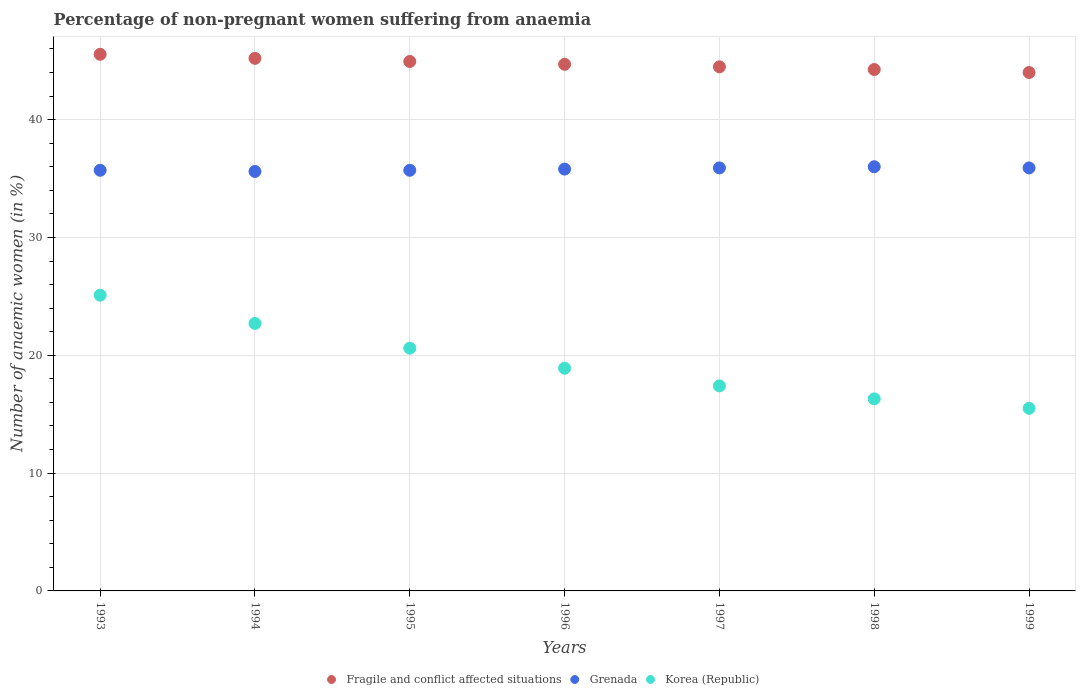Is the number of dotlines equal to the number of legend labels?
Your answer should be very brief. Yes. What is the percentage of non-pregnant women suffering from anaemia in Fragile and conflict affected situations in 1994?
Ensure brevity in your answer.  45.2. Across all years, what is the maximum percentage of non-pregnant women suffering from anaemia in Fragile and conflict affected situations?
Offer a terse response. 45.54. In which year was the percentage of non-pregnant women suffering from anaemia in Korea (Republic) maximum?
Your answer should be compact. 1993. In which year was the percentage of non-pregnant women suffering from anaemia in Korea (Republic) minimum?
Offer a very short reply. 1999. What is the total percentage of non-pregnant women suffering from anaemia in Grenada in the graph?
Offer a very short reply. 250.6. What is the difference between the percentage of non-pregnant women suffering from anaemia in Grenada in 1996 and that in 1999?
Provide a succinct answer. -0.1. What is the difference between the percentage of non-pregnant women suffering from anaemia in Fragile and conflict affected situations in 1993 and the percentage of non-pregnant women suffering from anaemia in Korea (Republic) in 1995?
Your response must be concise. 24.94. What is the average percentage of non-pregnant women suffering from anaemia in Korea (Republic) per year?
Ensure brevity in your answer.  19.5. What is the ratio of the percentage of non-pregnant women suffering from anaemia in Fragile and conflict affected situations in 1995 to that in 1997?
Offer a very short reply. 1.01. Is the percentage of non-pregnant women suffering from anaemia in Grenada in 1997 less than that in 1999?
Your answer should be compact. No. Is the difference between the percentage of non-pregnant women suffering from anaemia in Grenada in 1995 and 1998 greater than the difference between the percentage of non-pregnant women suffering from anaemia in Korea (Republic) in 1995 and 1998?
Ensure brevity in your answer.  No. What is the difference between the highest and the second highest percentage of non-pregnant women suffering from anaemia in Grenada?
Your answer should be compact. 0.1. What is the difference between the highest and the lowest percentage of non-pregnant women suffering from anaemia in Grenada?
Keep it short and to the point. 0.4. Is the sum of the percentage of non-pregnant women suffering from anaemia in Grenada in 1993 and 1994 greater than the maximum percentage of non-pregnant women suffering from anaemia in Fragile and conflict affected situations across all years?
Your answer should be very brief. Yes. Does the percentage of non-pregnant women suffering from anaemia in Korea (Republic) monotonically increase over the years?
Give a very brief answer. No. Is the percentage of non-pregnant women suffering from anaemia in Fragile and conflict affected situations strictly greater than the percentage of non-pregnant women suffering from anaemia in Grenada over the years?
Make the answer very short. Yes. What is the difference between two consecutive major ticks on the Y-axis?
Ensure brevity in your answer.  10. Does the graph contain any zero values?
Make the answer very short. No. What is the title of the graph?
Make the answer very short. Percentage of non-pregnant women suffering from anaemia. Does "Mauritania" appear as one of the legend labels in the graph?
Your answer should be compact. No. What is the label or title of the X-axis?
Your response must be concise. Years. What is the label or title of the Y-axis?
Your answer should be very brief. Number of anaemic women (in %). What is the Number of anaemic women (in %) of Fragile and conflict affected situations in 1993?
Provide a short and direct response. 45.54. What is the Number of anaemic women (in %) in Grenada in 1993?
Offer a terse response. 35.7. What is the Number of anaemic women (in %) of Korea (Republic) in 1993?
Your answer should be compact. 25.1. What is the Number of anaemic women (in %) of Fragile and conflict affected situations in 1994?
Offer a very short reply. 45.2. What is the Number of anaemic women (in %) in Grenada in 1994?
Your answer should be very brief. 35.6. What is the Number of anaemic women (in %) of Korea (Republic) in 1994?
Provide a short and direct response. 22.7. What is the Number of anaemic women (in %) of Fragile and conflict affected situations in 1995?
Provide a short and direct response. 44.93. What is the Number of anaemic women (in %) in Grenada in 1995?
Your response must be concise. 35.7. What is the Number of anaemic women (in %) in Korea (Republic) in 1995?
Your answer should be very brief. 20.6. What is the Number of anaemic women (in %) of Fragile and conflict affected situations in 1996?
Your answer should be very brief. 44.69. What is the Number of anaemic women (in %) in Grenada in 1996?
Your response must be concise. 35.8. What is the Number of anaemic women (in %) in Korea (Republic) in 1996?
Ensure brevity in your answer.  18.9. What is the Number of anaemic women (in %) of Fragile and conflict affected situations in 1997?
Your answer should be compact. 44.48. What is the Number of anaemic women (in %) in Grenada in 1997?
Your answer should be very brief. 35.9. What is the Number of anaemic women (in %) in Korea (Republic) in 1997?
Offer a terse response. 17.4. What is the Number of anaemic women (in %) in Fragile and conflict affected situations in 1998?
Provide a succinct answer. 44.25. What is the Number of anaemic women (in %) of Grenada in 1998?
Offer a terse response. 36. What is the Number of anaemic women (in %) in Korea (Republic) in 1998?
Make the answer very short. 16.3. What is the Number of anaemic women (in %) in Fragile and conflict affected situations in 1999?
Offer a terse response. 44. What is the Number of anaemic women (in %) of Grenada in 1999?
Your answer should be compact. 35.9. Across all years, what is the maximum Number of anaemic women (in %) in Fragile and conflict affected situations?
Your answer should be very brief. 45.54. Across all years, what is the maximum Number of anaemic women (in %) in Korea (Republic)?
Provide a short and direct response. 25.1. Across all years, what is the minimum Number of anaemic women (in %) in Fragile and conflict affected situations?
Provide a short and direct response. 44. Across all years, what is the minimum Number of anaemic women (in %) in Grenada?
Your answer should be very brief. 35.6. Across all years, what is the minimum Number of anaemic women (in %) of Korea (Republic)?
Provide a succinct answer. 15.5. What is the total Number of anaemic women (in %) in Fragile and conflict affected situations in the graph?
Ensure brevity in your answer.  313.1. What is the total Number of anaemic women (in %) in Grenada in the graph?
Your answer should be compact. 250.6. What is the total Number of anaemic women (in %) in Korea (Republic) in the graph?
Give a very brief answer. 136.5. What is the difference between the Number of anaemic women (in %) of Fragile and conflict affected situations in 1993 and that in 1994?
Give a very brief answer. 0.35. What is the difference between the Number of anaemic women (in %) of Grenada in 1993 and that in 1994?
Your answer should be compact. 0.1. What is the difference between the Number of anaemic women (in %) of Fragile and conflict affected situations in 1993 and that in 1995?
Ensure brevity in your answer.  0.61. What is the difference between the Number of anaemic women (in %) of Grenada in 1993 and that in 1995?
Provide a succinct answer. 0. What is the difference between the Number of anaemic women (in %) of Fragile and conflict affected situations in 1993 and that in 1996?
Your answer should be very brief. 0.85. What is the difference between the Number of anaemic women (in %) in Fragile and conflict affected situations in 1993 and that in 1997?
Your answer should be very brief. 1.07. What is the difference between the Number of anaemic women (in %) in Grenada in 1993 and that in 1997?
Offer a terse response. -0.2. What is the difference between the Number of anaemic women (in %) of Fragile and conflict affected situations in 1993 and that in 1998?
Provide a short and direct response. 1.29. What is the difference between the Number of anaemic women (in %) of Fragile and conflict affected situations in 1993 and that in 1999?
Provide a short and direct response. 1.55. What is the difference between the Number of anaemic women (in %) of Fragile and conflict affected situations in 1994 and that in 1995?
Provide a succinct answer. 0.27. What is the difference between the Number of anaemic women (in %) of Grenada in 1994 and that in 1995?
Offer a very short reply. -0.1. What is the difference between the Number of anaemic women (in %) of Korea (Republic) in 1994 and that in 1995?
Provide a short and direct response. 2.1. What is the difference between the Number of anaemic women (in %) in Fragile and conflict affected situations in 1994 and that in 1996?
Your answer should be compact. 0.51. What is the difference between the Number of anaemic women (in %) in Grenada in 1994 and that in 1996?
Your answer should be compact. -0.2. What is the difference between the Number of anaemic women (in %) of Korea (Republic) in 1994 and that in 1996?
Offer a terse response. 3.8. What is the difference between the Number of anaemic women (in %) in Fragile and conflict affected situations in 1994 and that in 1997?
Provide a succinct answer. 0.72. What is the difference between the Number of anaemic women (in %) in Grenada in 1994 and that in 1997?
Your answer should be very brief. -0.3. What is the difference between the Number of anaemic women (in %) in Korea (Republic) in 1994 and that in 1997?
Your response must be concise. 5.3. What is the difference between the Number of anaemic women (in %) in Fragile and conflict affected situations in 1994 and that in 1998?
Offer a terse response. 0.95. What is the difference between the Number of anaemic women (in %) of Fragile and conflict affected situations in 1994 and that in 1999?
Offer a very short reply. 1.2. What is the difference between the Number of anaemic women (in %) in Korea (Republic) in 1994 and that in 1999?
Provide a short and direct response. 7.2. What is the difference between the Number of anaemic women (in %) in Fragile and conflict affected situations in 1995 and that in 1996?
Keep it short and to the point. 0.24. What is the difference between the Number of anaemic women (in %) in Grenada in 1995 and that in 1996?
Offer a very short reply. -0.1. What is the difference between the Number of anaemic women (in %) of Fragile and conflict affected situations in 1995 and that in 1997?
Offer a terse response. 0.45. What is the difference between the Number of anaemic women (in %) in Fragile and conflict affected situations in 1995 and that in 1998?
Your answer should be compact. 0.68. What is the difference between the Number of anaemic women (in %) of Korea (Republic) in 1995 and that in 1998?
Provide a short and direct response. 4.3. What is the difference between the Number of anaemic women (in %) of Fragile and conflict affected situations in 1995 and that in 1999?
Provide a short and direct response. 0.94. What is the difference between the Number of anaemic women (in %) of Korea (Republic) in 1995 and that in 1999?
Make the answer very short. 5.1. What is the difference between the Number of anaemic women (in %) of Fragile and conflict affected situations in 1996 and that in 1997?
Make the answer very short. 0.21. What is the difference between the Number of anaemic women (in %) in Korea (Republic) in 1996 and that in 1997?
Offer a terse response. 1.5. What is the difference between the Number of anaemic women (in %) in Fragile and conflict affected situations in 1996 and that in 1998?
Provide a succinct answer. 0.44. What is the difference between the Number of anaemic women (in %) of Grenada in 1996 and that in 1998?
Offer a very short reply. -0.2. What is the difference between the Number of anaemic women (in %) of Fragile and conflict affected situations in 1996 and that in 1999?
Provide a short and direct response. 0.7. What is the difference between the Number of anaemic women (in %) in Fragile and conflict affected situations in 1997 and that in 1998?
Keep it short and to the point. 0.23. What is the difference between the Number of anaemic women (in %) of Grenada in 1997 and that in 1998?
Your answer should be very brief. -0.1. What is the difference between the Number of anaemic women (in %) of Fragile and conflict affected situations in 1997 and that in 1999?
Your answer should be very brief. 0.48. What is the difference between the Number of anaemic women (in %) in Korea (Republic) in 1997 and that in 1999?
Your answer should be compact. 1.9. What is the difference between the Number of anaemic women (in %) in Fragile and conflict affected situations in 1998 and that in 1999?
Provide a succinct answer. 0.25. What is the difference between the Number of anaemic women (in %) of Korea (Republic) in 1998 and that in 1999?
Give a very brief answer. 0.8. What is the difference between the Number of anaemic women (in %) of Fragile and conflict affected situations in 1993 and the Number of anaemic women (in %) of Grenada in 1994?
Offer a terse response. 9.94. What is the difference between the Number of anaemic women (in %) of Fragile and conflict affected situations in 1993 and the Number of anaemic women (in %) of Korea (Republic) in 1994?
Provide a short and direct response. 22.84. What is the difference between the Number of anaemic women (in %) of Fragile and conflict affected situations in 1993 and the Number of anaemic women (in %) of Grenada in 1995?
Your answer should be very brief. 9.84. What is the difference between the Number of anaemic women (in %) in Fragile and conflict affected situations in 1993 and the Number of anaemic women (in %) in Korea (Republic) in 1995?
Ensure brevity in your answer.  24.94. What is the difference between the Number of anaemic women (in %) in Fragile and conflict affected situations in 1993 and the Number of anaemic women (in %) in Grenada in 1996?
Keep it short and to the point. 9.74. What is the difference between the Number of anaemic women (in %) of Fragile and conflict affected situations in 1993 and the Number of anaemic women (in %) of Korea (Republic) in 1996?
Offer a terse response. 26.64. What is the difference between the Number of anaemic women (in %) of Grenada in 1993 and the Number of anaemic women (in %) of Korea (Republic) in 1996?
Make the answer very short. 16.8. What is the difference between the Number of anaemic women (in %) in Fragile and conflict affected situations in 1993 and the Number of anaemic women (in %) in Grenada in 1997?
Make the answer very short. 9.64. What is the difference between the Number of anaemic women (in %) in Fragile and conflict affected situations in 1993 and the Number of anaemic women (in %) in Korea (Republic) in 1997?
Provide a short and direct response. 28.14. What is the difference between the Number of anaemic women (in %) in Fragile and conflict affected situations in 1993 and the Number of anaemic women (in %) in Grenada in 1998?
Ensure brevity in your answer.  9.54. What is the difference between the Number of anaemic women (in %) of Fragile and conflict affected situations in 1993 and the Number of anaemic women (in %) of Korea (Republic) in 1998?
Provide a succinct answer. 29.24. What is the difference between the Number of anaemic women (in %) of Fragile and conflict affected situations in 1993 and the Number of anaemic women (in %) of Grenada in 1999?
Make the answer very short. 9.64. What is the difference between the Number of anaemic women (in %) in Fragile and conflict affected situations in 1993 and the Number of anaemic women (in %) in Korea (Republic) in 1999?
Your answer should be compact. 30.04. What is the difference between the Number of anaemic women (in %) in Grenada in 1993 and the Number of anaemic women (in %) in Korea (Republic) in 1999?
Your answer should be compact. 20.2. What is the difference between the Number of anaemic women (in %) in Fragile and conflict affected situations in 1994 and the Number of anaemic women (in %) in Grenada in 1995?
Provide a short and direct response. 9.5. What is the difference between the Number of anaemic women (in %) in Fragile and conflict affected situations in 1994 and the Number of anaemic women (in %) in Korea (Republic) in 1995?
Give a very brief answer. 24.6. What is the difference between the Number of anaemic women (in %) in Fragile and conflict affected situations in 1994 and the Number of anaemic women (in %) in Grenada in 1996?
Provide a short and direct response. 9.4. What is the difference between the Number of anaemic women (in %) in Fragile and conflict affected situations in 1994 and the Number of anaemic women (in %) in Korea (Republic) in 1996?
Provide a succinct answer. 26.3. What is the difference between the Number of anaemic women (in %) of Fragile and conflict affected situations in 1994 and the Number of anaemic women (in %) of Grenada in 1997?
Your response must be concise. 9.3. What is the difference between the Number of anaemic women (in %) in Fragile and conflict affected situations in 1994 and the Number of anaemic women (in %) in Korea (Republic) in 1997?
Give a very brief answer. 27.8. What is the difference between the Number of anaemic women (in %) in Grenada in 1994 and the Number of anaemic women (in %) in Korea (Republic) in 1997?
Give a very brief answer. 18.2. What is the difference between the Number of anaemic women (in %) in Fragile and conflict affected situations in 1994 and the Number of anaemic women (in %) in Grenada in 1998?
Make the answer very short. 9.2. What is the difference between the Number of anaemic women (in %) in Fragile and conflict affected situations in 1994 and the Number of anaemic women (in %) in Korea (Republic) in 1998?
Your response must be concise. 28.9. What is the difference between the Number of anaemic women (in %) of Grenada in 1994 and the Number of anaemic women (in %) of Korea (Republic) in 1998?
Your answer should be compact. 19.3. What is the difference between the Number of anaemic women (in %) of Fragile and conflict affected situations in 1994 and the Number of anaemic women (in %) of Grenada in 1999?
Your response must be concise. 9.3. What is the difference between the Number of anaemic women (in %) in Fragile and conflict affected situations in 1994 and the Number of anaemic women (in %) in Korea (Republic) in 1999?
Offer a terse response. 29.7. What is the difference between the Number of anaemic women (in %) of Grenada in 1994 and the Number of anaemic women (in %) of Korea (Republic) in 1999?
Give a very brief answer. 20.1. What is the difference between the Number of anaemic women (in %) of Fragile and conflict affected situations in 1995 and the Number of anaemic women (in %) of Grenada in 1996?
Ensure brevity in your answer.  9.13. What is the difference between the Number of anaemic women (in %) of Fragile and conflict affected situations in 1995 and the Number of anaemic women (in %) of Korea (Republic) in 1996?
Give a very brief answer. 26.03. What is the difference between the Number of anaemic women (in %) in Grenada in 1995 and the Number of anaemic women (in %) in Korea (Republic) in 1996?
Make the answer very short. 16.8. What is the difference between the Number of anaemic women (in %) of Fragile and conflict affected situations in 1995 and the Number of anaemic women (in %) of Grenada in 1997?
Your answer should be compact. 9.03. What is the difference between the Number of anaemic women (in %) of Fragile and conflict affected situations in 1995 and the Number of anaemic women (in %) of Korea (Republic) in 1997?
Your response must be concise. 27.53. What is the difference between the Number of anaemic women (in %) in Fragile and conflict affected situations in 1995 and the Number of anaemic women (in %) in Grenada in 1998?
Give a very brief answer. 8.93. What is the difference between the Number of anaemic women (in %) of Fragile and conflict affected situations in 1995 and the Number of anaemic women (in %) of Korea (Republic) in 1998?
Your answer should be compact. 28.63. What is the difference between the Number of anaemic women (in %) of Fragile and conflict affected situations in 1995 and the Number of anaemic women (in %) of Grenada in 1999?
Give a very brief answer. 9.03. What is the difference between the Number of anaemic women (in %) of Fragile and conflict affected situations in 1995 and the Number of anaemic women (in %) of Korea (Republic) in 1999?
Your answer should be very brief. 29.43. What is the difference between the Number of anaemic women (in %) in Grenada in 1995 and the Number of anaemic women (in %) in Korea (Republic) in 1999?
Keep it short and to the point. 20.2. What is the difference between the Number of anaemic women (in %) of Fragile and conflict affected situations in 1996 and the Number of anaemic women (in %) of Grenada in 1997?
Your answer should be very brief. 8.79. What is the difference between the Number of anaemic women (in %) of Fragile and conflict affected situations in 1996 and the Number of anaemic women (in %) of Korea (Republic) in 1997?
Your answer should be very brief. 27.29. What is the difference between the Number of anaemic women (in %) of Grenada in 1996 and the Number of anaemic women (in %) of Korea (Republic) in 1997?
Make the answer very short. 18.4. What is the difference between the Number of anaemic women (in %) of Fragile and conflict affected situations in 1996 and the Number of anaemic women (in %) of Grenada in 1998?
Make the answer very short. 8.69. What is the difference between the Number of anaemic women (in %) of Fragile and conflict affected situations in 1996 and the Number of anaemic women (in %) of Korea (Republic) in 1998?
Your response must be concise. 28.39. What is the difference between the Number of anaemic women (in %) of Grenada in 1996 and the Number of anaemic women (in %) of Korea (Republic) in 1998?
Keep it short and to the point. 19.5. What is the difference between the Number of anaemic women (in %) of Fragile and conflict affected situations in 1996 and the Number of anaemic women (in %) of Grenada in 1999?
Your response must be concise. 8.79. What is the difference between the Number of anaemic women (in %) in Fragile and conflict affected situations in 1996 and the Number of anaemic women (in %) in Korea (Republic) in 1999?
Ensure brevity in your answer.  29.19. What is the difference between the Number of anaemic women (in %) of Grenada in 1996 and the Number of anaemic women (in %) of Korea (Republic) in 1999?
Provide a short and direct response. 20.3. What is the difference between the Number of anaemic women (in %) of Fragile and conflict affected situations in 1997 and the Number of anaemic women (in %) of Grenada in 1998?
Your answer should be compact. 8.48. What is the difference between the Number of anaemic women (in %) of Fragile and conflict affected situations in 1997 and the Number of anaemic women (in %) of Korea (Republic) in 1998?
Make the answer very short. 28.18. What is the difference between the Number of anaemic women (in %) in Grenada in 1997 and the Number of anaemic women (in %) in Korea (Republic) in 1998?
Provide a short and direct response. 19.6. What is the difference between the Number of anaemic women (in %) in Fragile and conflict affected situations in 1997 and the Number of anaemic women (in %) in Grenada in 1999?
Your response must be concise. 8.58. What is the difference between the Number of anaemic women (in %) of Fragile and conflict affected situations in 1997 and the Number of anaemic women (in %) of Korea (Republic) in 1999?
Your answer should be compact. 28.98. What is the difference between the Number of anaemic women (in %) in Grenada in 1997 and the Number of anaemic women (in %) in Korea (Republic) in 1999?
Keep it short and to the point. 20.4. What is the difference between the Number of anaemic women (in %) of Fragile and conflict affected situations in 1998 and the Number of anaemic women (in %) of Grenada in 1999?
Make the answer very short. 8.35. What is the difference between the Number of anaemic women (in %) of Fragile and conflict affected situations in 1998 and the Number of anaemic women (in %) of Korea (Republic) in 1999?
Make the answer very short. 28.75. What is the average Number of anaemic women (in %) in Fragile and conflict affected situations per year?
Give a very brief answer. 44.73. What is the average Number of anaemic women (in %) of Grenada per year?
Your answer should be very brief. 35.8. What is the average Number of anaemic women (in %) in Korea (Republic) per year?
Offer a very short reply. 19.5. In the year 1993, what is the difference between the Number of anaemic women (in %) of Fragile and conflict affected situations and Number of anaemic women (in %) of Grenada?
Give a very brief answer. 9.84. In the year 1993, what is the difference between the Number of anaemic women (in %) in Fragile and conflict affected situations and Number of anaemic women (in %) in Korea (Republic)?
Give a very brief answer. 20.44. In the year 1994, what is the difference between the Number of anaemic women (in %) in Fragile and conflict affected situations and Number of anaemic women (in %) in Grenada?
Make the answer very short. 9.6. In the year 1994, what is the difference between the Number of anaemic women (in %) of Fragile and conflict affected situations and Number of anaemic women (in %) of Korea (Republic)?
Your answer should be very brief. 22.5. In the year 1994, what is the difference between the Number of anaemic women (in %) in Grenada and Number of anaemic women (in %) in Korea (Republic)?
Your response must be concise. 12.9. In the year 1995, what is the difference between the Number of anaemic women (in %) in Fragile and conflict affected situations and Number of anaemic women (in %) in Grenada?
Offer a very short reply. 9.23. In the year 1995, what is the difference between the Number of anaemic women (in %) of Fragile and conflict affected situations and Number of anaemic women (in %) of Korea (Republic)?
Ensure brevity in your answer.  24.33. In the year 1996, what is the difference between the Number of anaemic women (in %) in Fragile and conflict affected situations and Number of anaemic women (in %) in Grenada?
Your answer should be very brief. 8.89. In the year 1996, what is the difference between the Number of anaemic women (in %) of Fragile and conflict affected situations and Number of anaemic women (in %) of Korea (Republic)?
Your answer should be very brief. 25.79. In the year 1996, what is the difference between the Number of anaemic women (in %) in Grenada and Number of anaemic women (in %) in Korea (Republic)?
Provide a short and direct response. 16.9. In the year 1997, what is the difference between the Number of anaemic women (in %) in Fragile and conflict affected situations and Number of anaemic women (in %) in Grenada?
Offer a very short reply. 8.58. In the year 1997, what is the difference between the Number of anaemic women (in %) of Fragile and conflict affected situations and Number of anaemic women (in %) of Korea (Republic)?
Your response must be concise. 27.08. In the year 1998, what is the difference between the Number of anaemic women (in %) of Fragile and conflict affected situations and Number of anaemic women (in %) of Grenada?
Give a very brief answer. 8.25. In the year 1998, what is the difference between the Number of anaemic women (in %) in Fragile and conflict affected situations and Number of anaemic women (in %) in Korea (Republic)?
Offer a terse response. 27.95. In the year 1999, what is the difference between the Number of anaemic women (in %) of Fragile and conflict affected situations and Number of anaemic women (in %) of Grenada?
Keep it short and to the point. 8.1. In the year 1999, what is the difference between the Number of anaemic women (in %) in Fragile and conflict affected situations and Number of anaemic women (in %) in Korea (Republic)?
Provide a short and direct response. 28.5. In the year 1999, what is the difference between the Number of anaemic women (in %) of Grenada and Number of anaemic women (in %) of Korea (Republic)?
Provide a short and direct response. 20.4. What is the ratio of the Number of anaemic women (in %) of Fragile and conflict affected situations in 1993 to that in 1994?
Provide a succinct answer. 1.01. What is the ratio of the Number of anaemic women (in %) in Grenada in 1993 to that in 1994?
Provide a succinct answer. 1. What is the ratio of the Number of anaemic women (in %) in Korea (Republic) in 1993 to that in 1994?
Provide a short and direct response. 1.11. What is the ratio of the Number of anaemic women (in %) of Fragile and conflict affected situations in 1993 to that in 1995?
Provide a short and direct response. 1.01. What is the ratio of the Number of anaemic women (in %) in Grenada in 1993 to that in 1995?
Offer a terse response. 1. What is the ratio of the Number of anaemic women (in %) in Korea (Republic) in 1993 to that in 1995?
Offer a very short reply. 1.22. What is the ratio of the Number of anaemic women (in %) in Fragile and conflict affected situations in 1993 to that in 1996?
Your response must be concise. 1.02. What is the ratio of the Number of anaemic women (in %) in Korea (Republic) in 1993 to that in 1996?
Your answer should be very brief. 1.33. What is the ratio of the Number of anaemic women (in %) in Fragile and conflict affected situations in 1993 to that in 1997?
Your answer should be very brief. 1.02. What is the ratio of the Number of anaemic women (in %) in Grenada in 1993 to that in 1997?
Give a very brief answer. 0.99. What is the ratio of the Number of anaemic women (in %) of Korea (Republic) in 1993 to that in 1997?
Provide a short and direct response. 1.44. What is the ratio of the Number of anaemic women (in %) of Fragile and conflict affected situations in 1993 to that in 1998?
Your answer should be very brief. 1.03. What is the ratio of the Number of anaemic women (in %) in Korea (Republic) in 1993 to that in 1998?
Give a very brief answer. 1.54. What is the ratio of the Number of anaemic women (in %) of Fragile and conflict affected situations in 1993 to that in 1999?
Give a very brief answer. 1.04. What is the ratio of the Number of anaemic women (in %) of Korea (Republic) in 1993 to that in 1999?
Offer a terse response. 1.62. What is the ratio of the Number of anaemic women (in %) of Fragile and conflict affected situations in 1994 to that in 1995?
Ensure brevity in your answer.  1.01. What is the ratio of the Number of anaemic women (in %) of Korea (Republic) in 1994 to that in 1995?
Ensure brevity in your answer.  1.1. What is the ratio of the Number of anaemic women (in %) of Fragile and conflict affected situations in 1994 to that in 1996?
Your response must be concise. 1.01. What is the ratio of the Number of anaemic women (in %) of Grenada in 1994 to that in 1996?
Offer a terse response. 0.99. What is the ratio of the Number of anaemic women (in %) in Korea (Republic) in 1994 to that in 1996?
Offer a terse response. 1.2. What is the ratio of the Number of anaemic women (in %) in Fragile and conflict affected situations in 1994 to that in 1997?
Your response must be concise. 1.02. What is the ratio of the Number of anaemic women (in %) in Korea (Republic) in 1994 to that in 1997?
Provide a succinct answer. 1.3. What is the ratio of the Number of anaemic women (in %) of Fragile and conflict affected situations in 1994 to that in 1998?
Give a very brief answer. 1.02. What is the ratio of the Number of anaemic women (in %) in Grenada in 1994 to that in 1998?
Ensure brevity in your answer.  0.99. What is the ratio of the Number of anaemic women (in %) of Korea (Republic) in 1994 to that in 1998?
Your answer should be very brief. 1.39. What is the ratio of the Number of anaemic women (in %) of Fragile and conflict affected situations in 1994 to that in 1999?
Your answer should be very brief. 1.03. What is the ratio of the Number of anaemic women (in %) of Korea (Republic) in 1994 to that in 1999?
Provide a succinct answer. 1.46. What is the ratio of the Number of anaemic women (in %) in Fragile and conflict affected situations in 1995 to that in 1996?
Your response must be concise. 1.01. What is the ratio of the Number of anaemic women (in %) of Korea (Republic) in 1995 to that in 1996?
Keep it short and to the point. 1.09. What is the ratio of the Number of anaemic women (in %) in Fragile and conflict affected situations in 1995 to that in 1997?
Give a very brief answer. 1.01. What is the ratio of the Number of anaemic women (in %) of Grenada in 1995 to that in 1997?
Make the answer very short. 0.99. What is the ratio of the Number of anaemic women (in %) in Korea (Republic) in 1995 to that in 1997?
Your answer should be compact. 1.18. What is the ratio of the Number of anaemic women (in %) of Fragile and conflict affected situations in 1995 to that in 1998?
Your answer should be very brief. 1.02. What is the ratio of the Number of anaemic women (in %) of Grenada in 1995 to that in 1998?
Your answer should be compact. 0.99. What is the ratio of the Number of anaemic women (in %) of Korea (Republic) in 1995 to that in 1998?
Your response must be concise. 1.26. What is the ratio of the Number of anaemic women (in %) in Fragile and conflict affected situations in 1995 to that in 1999?
Provide a succinct answer. 1.02. What is the ratio of the Number of anaemic women (in %) of Grenada in 1995 to that in 1999?
Your answer should be compact. 0.99. What is the ratio of the Number of anaemic women (in %) of Korea (Republic) in 1995 to that in 1999?
Your answer should be compact. 1.33. What is the ratio of the Number of anaemic women (in %) of Grenada in 1996 to that in 1997?
Your response must be concise. 1. What is the ratio of the Number of anaemic women (in %) of Korea (Republic) in 1996 to that in 1997?
Provide a succinct answer. 1.09. What is the ratio of the Number of anaemic women (in %) in Fragile and conflict affected situations in 1996 to that in 1998?
Provide a succinct answer. 1.01. What is the ratio of the Number of anaemic women (in %) of Korea (Republic) in 1996 to that in 1998?
Offer a terse response. 1.16. What is the ratio of the Number of anaemic women (in %) of Fragile and conflict affected situations in 1996 to that in 1999?
Make the answer very short. 1.02. What is the ratio of the Number of anaemic women (in %) in Korea (Republic) in 1996 to that in 1999?
Offer a terse response. 1.22. What is the ratio of the Number of anaemic women (in %) in Grenada in 1997 to that in 1998?
Keep it short and to the point. 1. What is the ratio of the Number of anaemic women (in %) in Korea (Republic) in 1997 to that in 1998?
Give a very brief answer. 1.07. What is the ratio of the Number of anaemic women (in %) of Fragile and conflict affected situations in 1997 to that in 1999?
Give a very brief answer. 1.01. What is the ratio of the Number of anaemic women (in %) of Korea (Republic) in 1997 to that in 1999?
Offer a very short reply. 1.12. What is the ratio of the Number of anaemic women (in %) in Grenada in 1998 to that in 1999?
Ensure brevity in your answer.  1. What is the ratio of the Number of anaemic women (in %) in Korea (Republic) in 1998 to that in 1999?
Provide a succinct answer. 1.05. What is the difference between the highest and the second highest Number of anaemic women (in %) in Fragile and conflict affected situations?
Provide a short and direct response. 0.35. What is the difference between the highest and the second highest Number of anaemic women (in %) of Korea (Republic)?
Keep it short and to the point. 2.4. What is the difference between the highest and the lowest Number of anaemic women (in %) in Fragile and conflict affected situations?
Offer a terse response. 1.55. What is the difference between the highest and the lowest Number of anaemic women (in %) of Grenada?
Make the answer very short. 0.4. What is the difference between the highest and the lowest Number of anaemic women (in %) in Korea (Republic)?
Provide a succinct answer. 9.6. 